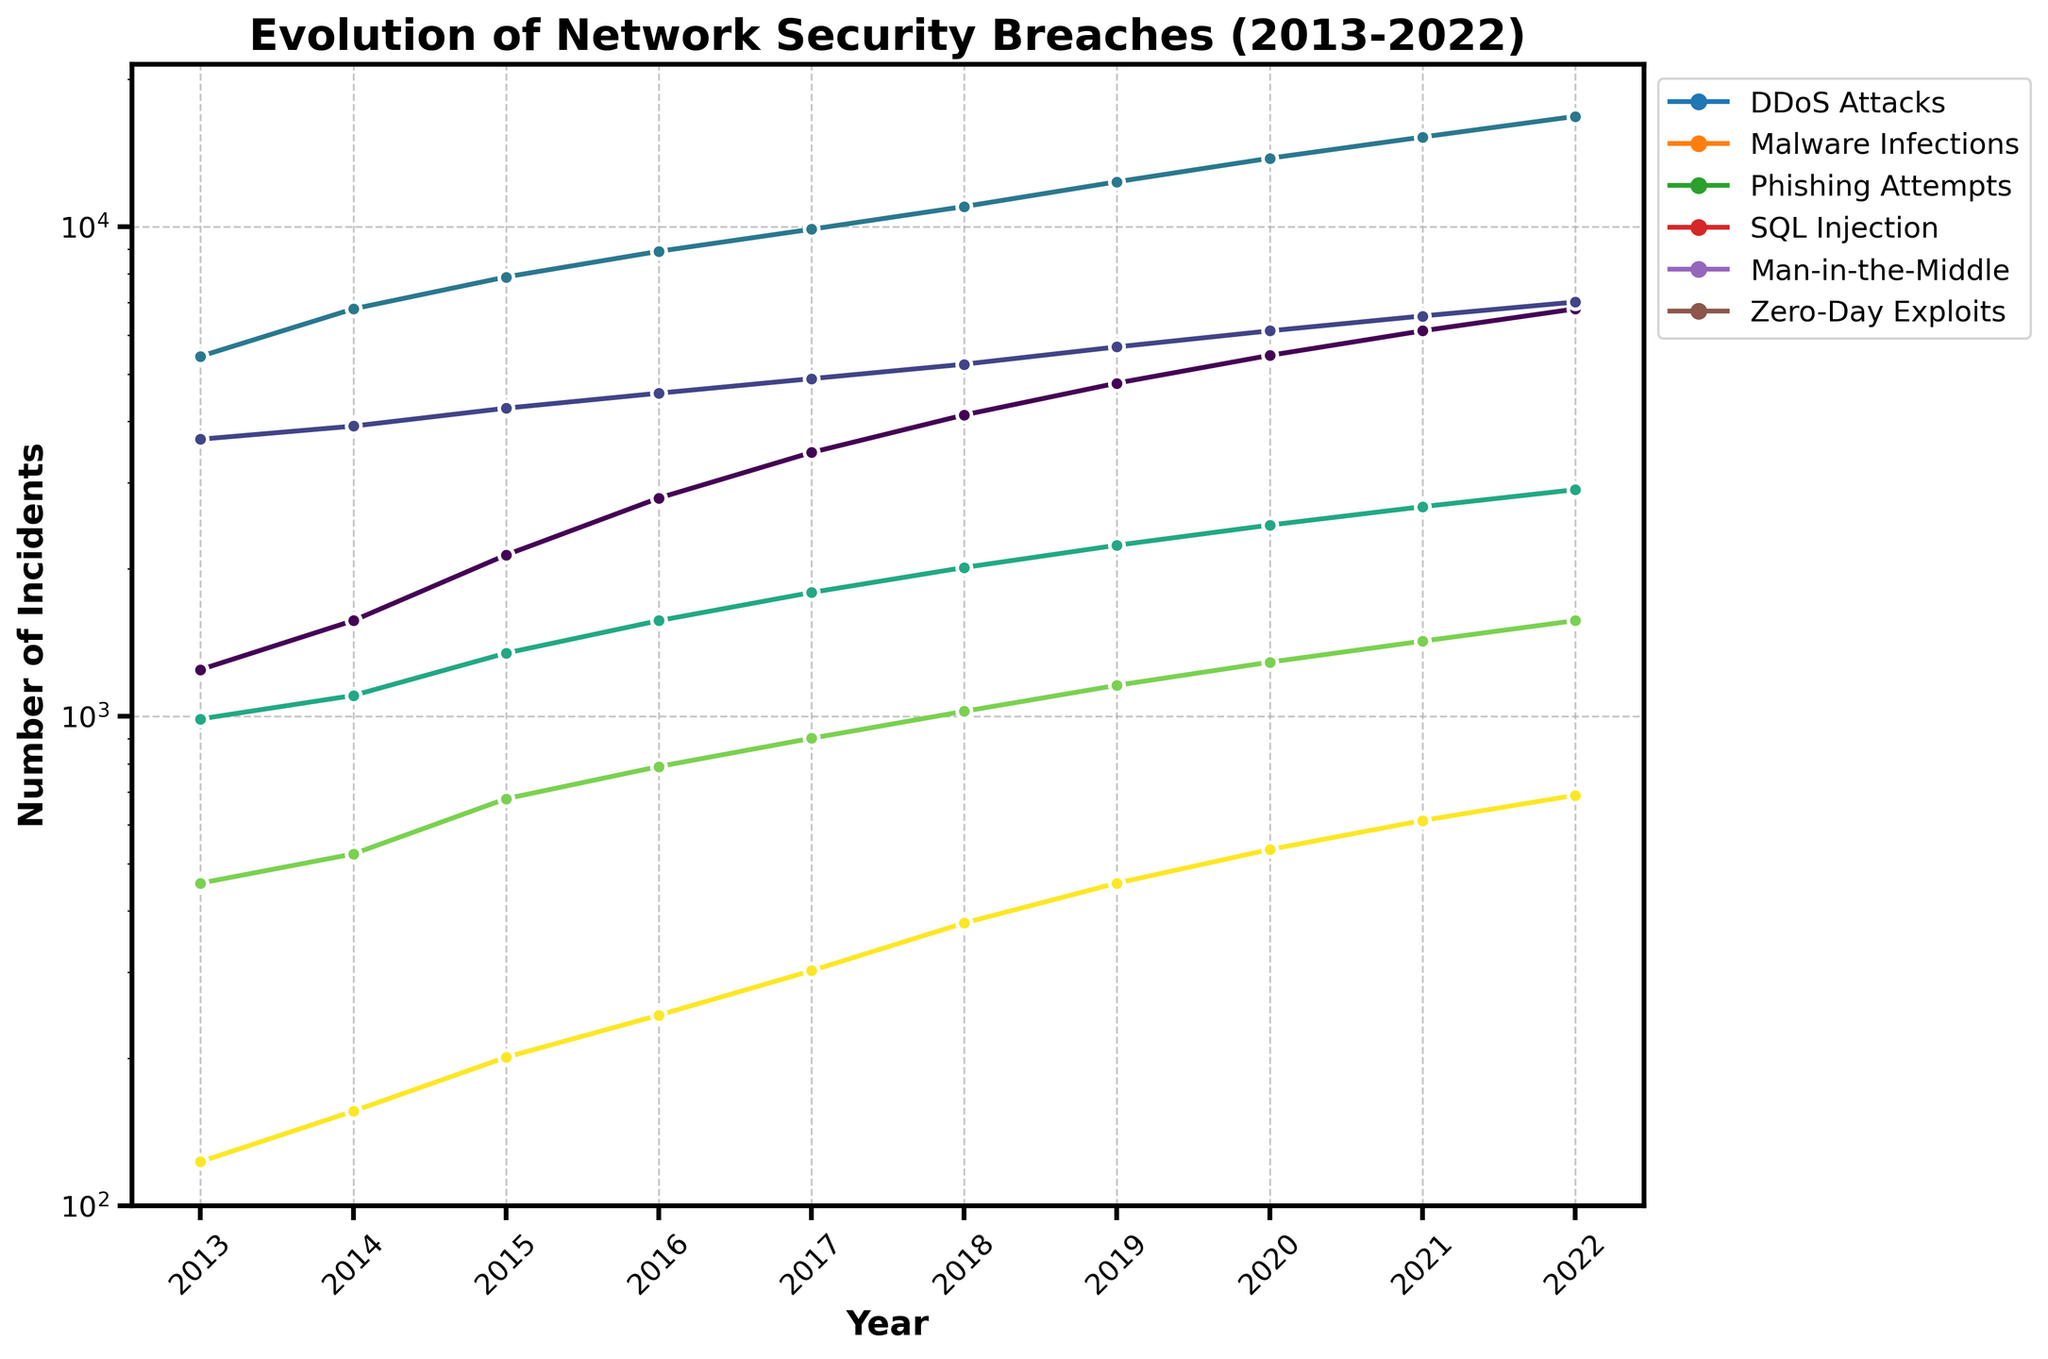What's the trend of DDoS attacks over the past decade? Examine the line for DDoS attacks in the figure. The number of incidents starts at 1245 in 2013 and steadily increases to 6789 by 2022. This indicates an upward trend.
Answer: Upward trend Which year had the highest number of Phishing Attempts? Look at the peak of the line corresponding to Phishing Attempts. The highest point is in 2022, with 16789 incidents.
Answer: 2022 How does the rate of increase of Malware Infections compare to Zero-Day Exploits from 2013 to 2022? Compare the slope of the lines for Malware Infections and Zero-Day Exploits. Malware Infections increased from 3678 to 7012, while Zero-Day Exploits increased from 123 to 689. The slope for Malware Infections is less steep compared to Zero-Day Exploits, indicating a slower rate of increase.
Answer: Slower What was the total number of incidents for SQL Injection in 2017 and 2018 combined? Identify the values for SQL Injection in 2017 (1789) and 2018 (2012), then sum them up. 1789 + 2012 = 3801.
Answer: 3801 Between which consecutive years did Man-in-the-Middle attacks see the greatest increase? Look for the biggest jump in the line corresponding to Man-in-the-Middle attacks between consecutive years. The increase from 2021 (1423) to 2022 (1567) is the greatest, which is 1567 - 1423 = 144.
Answer: 2021 to 2022 In which year did DDoS Attacks surpass the 2000 mark? Locate the year when the DDoS Attacks line crosses the 2000 line. This happens around mid-2015.
Answer: 2015 How much did the number of Zero-Day Exploits incidents grow from 2015 to 2022? Find the values for Zero-Day Exploits in 2015 (201) and 2022 (689), then calculate the difference. 689 - 201 = 488.
Answer: 488 Which type of network security breach had the slowest growth rate over the decade? Compare the lines for each type. The line for Man-in-the-Middle attacks shows the least steep increase from 456 in 2013 to 1567 in 2022, indicating the slowest growth rate.
Answer: Man-in-the-Middle Which breach type shows an exponential increase indicated by the trend in the logarithmic scale? In a logarithmic scale, an exponential increase appears as a straight line with a consistent steep slope. Both Phishing Attempts and Zero-Day Exploits seem to show this trend.
Answer: Phishing Attempts and Zero-Day Exploits What were the average number of SQL Injection incidents per year over the decade? Sum all the yearly incidents for SQL Injection and divide by the number of years. (987 + 1102 + 1345 + 1567 + 1789 + 2012 + 2234 + 2456 + 2678 + 2901) / 10 = 19071 / 10 = 1907.1.
Answer: 1907.1 